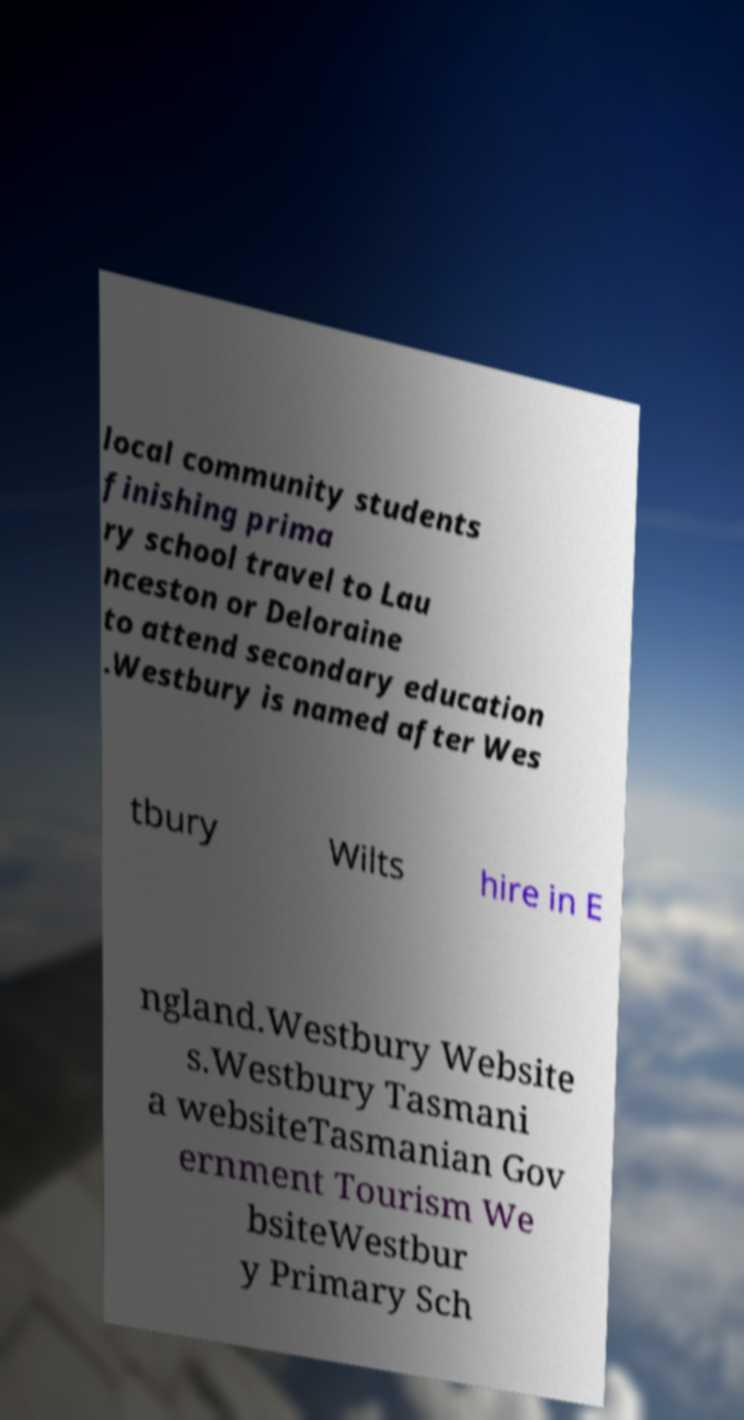Can you read and provide the text displayed in the image?This photo seems to have some interesting text. Can you extract and type it out for me? local community students finishing prima ry school travel to Lau nceston or Deloraine to attend secondary education .Westbury is named after Wes tbury Wilts hire in E ngland.Westbury Website s.Westbury Tasmani a websiteTasmanian Gov ernment Tourism We bsiteWestbur y Primary Sch 